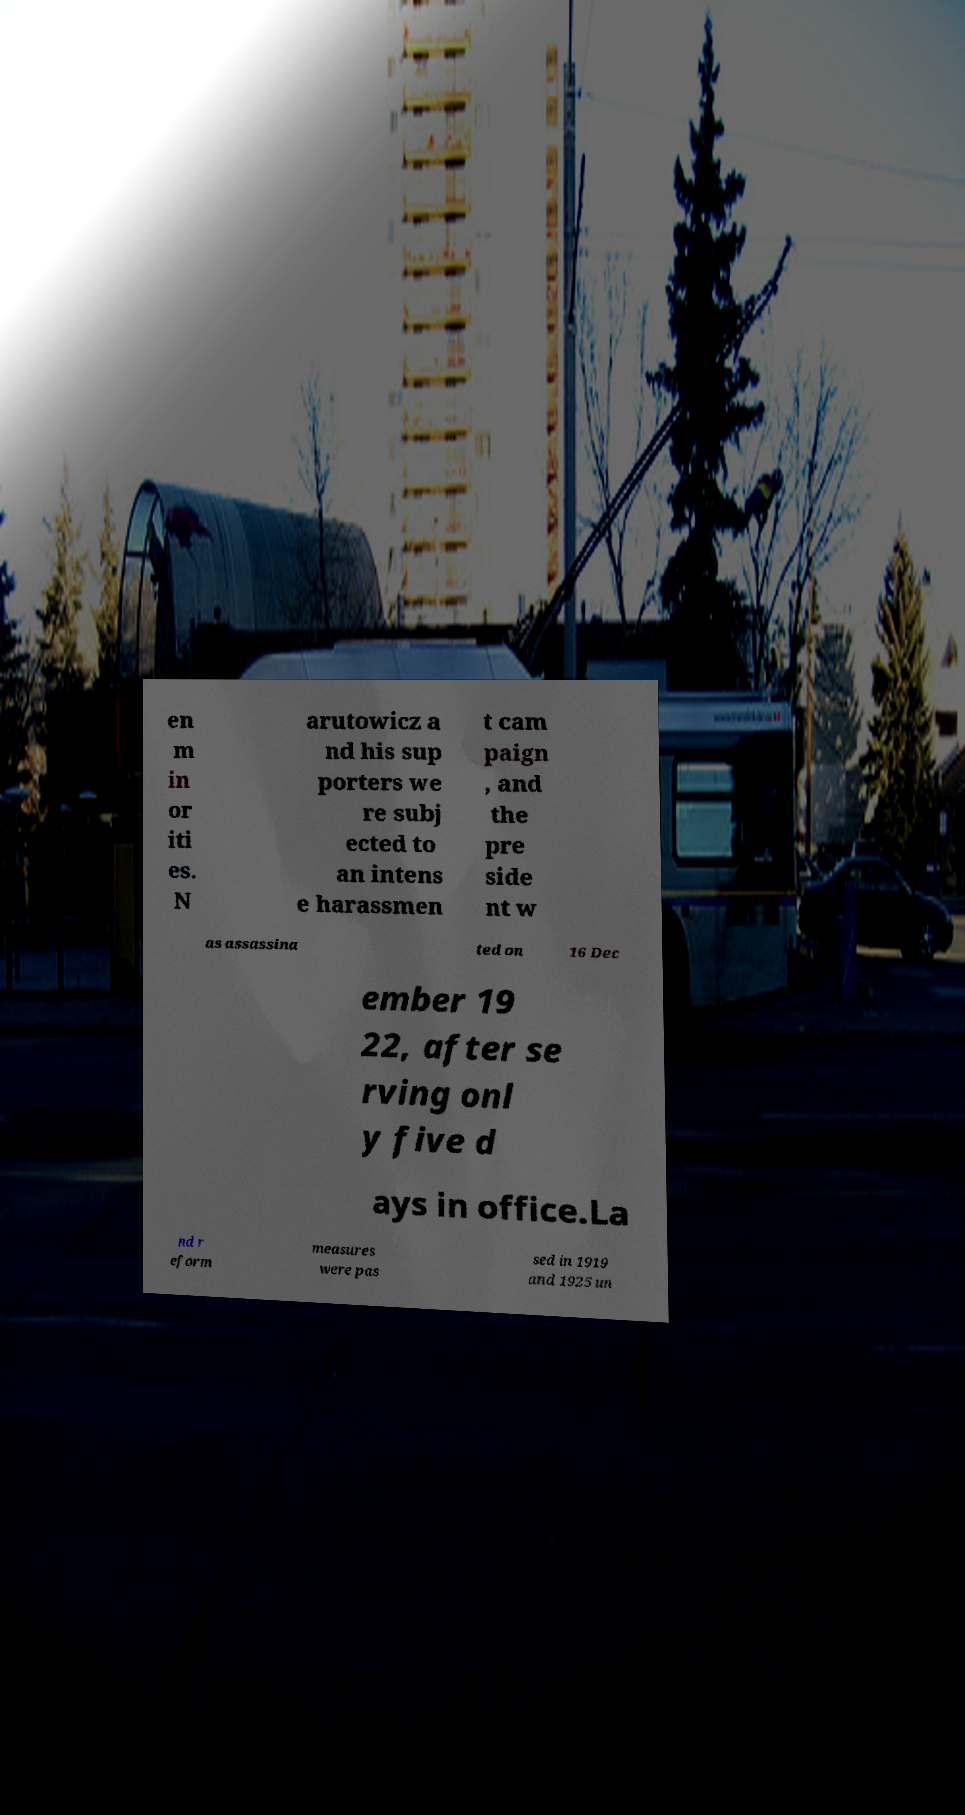Please identify and transcribe the text found in this image. en m in or iti es. N arutowicz a nd his sup porters we re subj ected to an intens e harassmen t cam paign , and the pre side nt w as assassina ted on 16 Dec ember 19 22, after se rving onl y five d ays in office.La nd r eform measures were pas sed in 1919 and 1925 un 